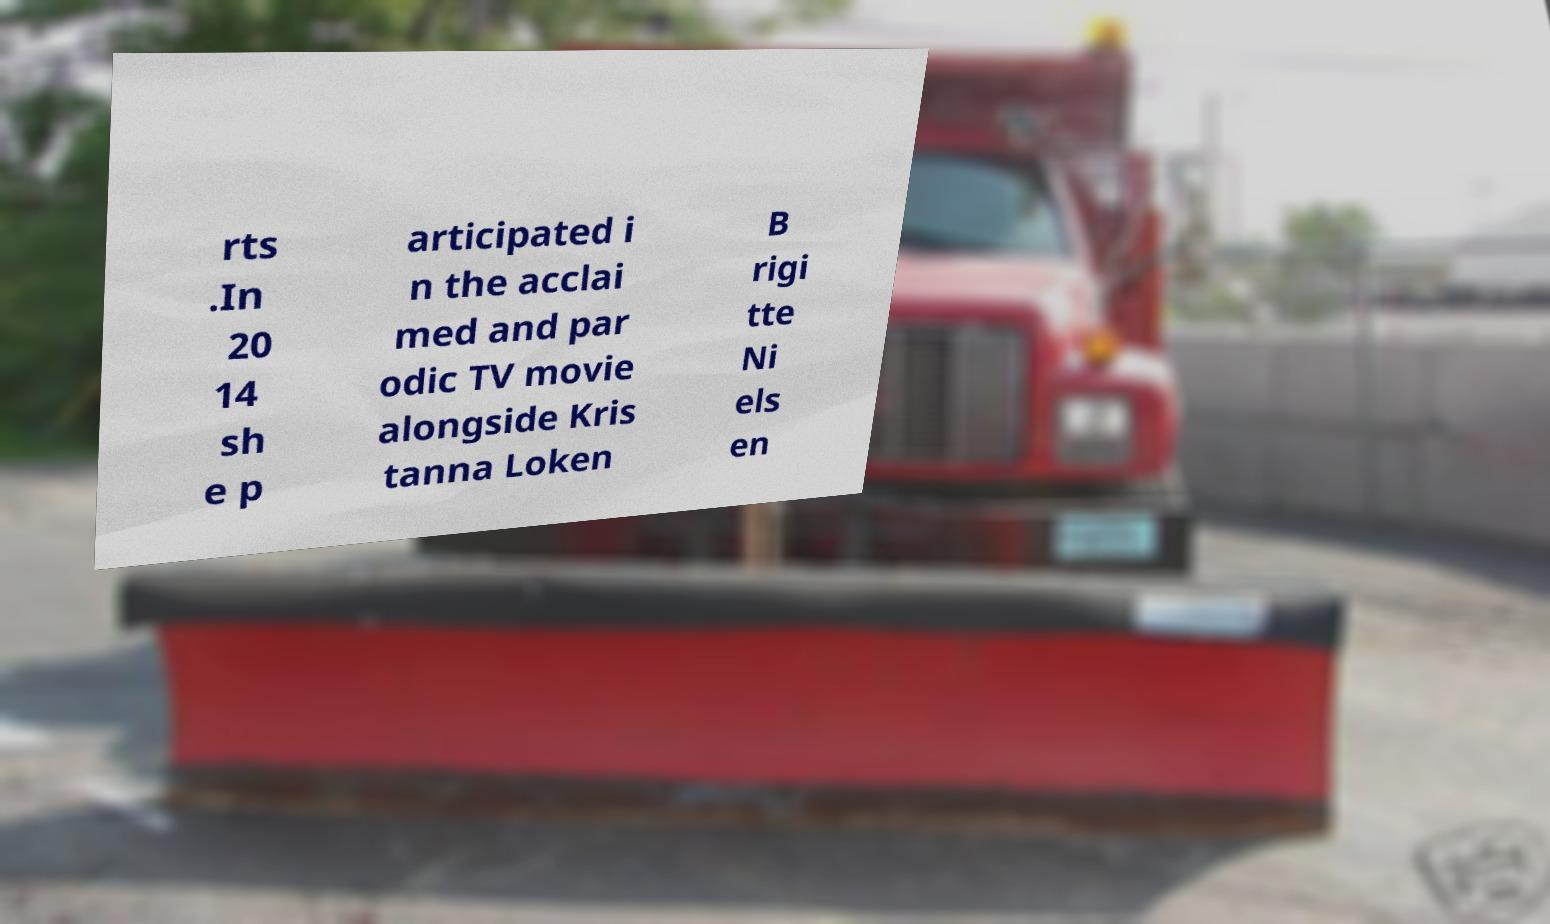For documentation purposes, I need the text within this image transcribed. Could you provide that? rts .In 20 14 sh e p articipated i n the acclai med and par odic TV movie alongside Kris tanna Loken B rigi tte Ni els en 